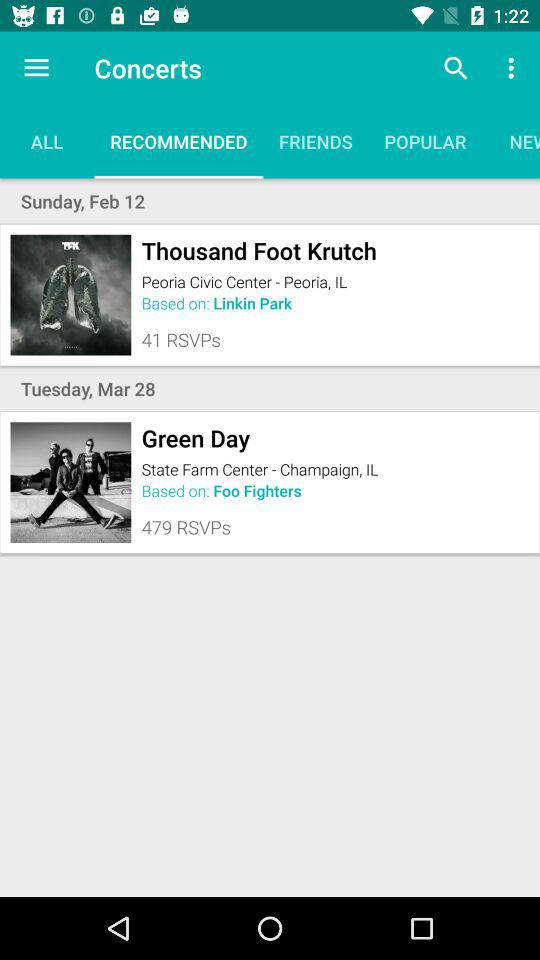Which tab am I on? You are on "RECOMMENDED" tab. 